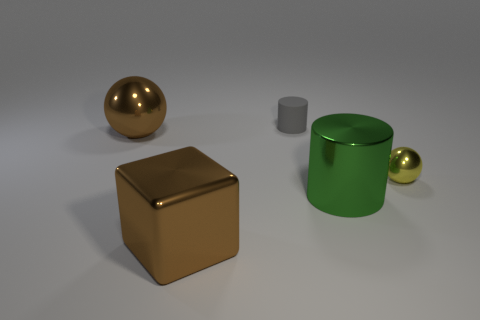Add 3 yellow balls. How many objects exist? 8 Subtract all green cylinders. How many cylinders are left? 1 Subtract 1 blocks. How many blocks are left? 0 Add 4 brown metal spheres. How many brown metal spheres are left? 5 Add 1 green metallic objects. How many green metallic objects exist? 2 Subtract 0 yellow cylinders. How many objects are left? 5 Subtract all cylinders. How many objects are left? 3 Subtract all green blocks. Subtract all brown cylinders. How many blocks are left? 1 Subtract all red blocks. How many green cylinders are left? 1 Subtract all spheres. Subtract all cylinders. How many objects are left? 1 